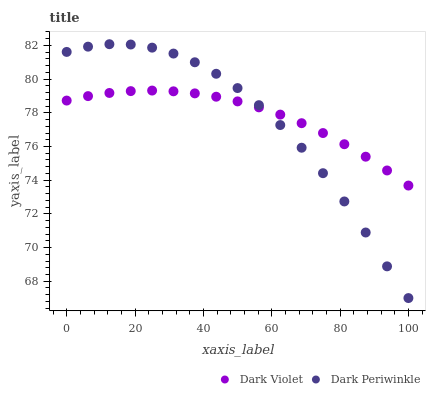Does Dark Periwinkle have the minimum area under the curve?
Answer yes or no. Yes. Does Dark Violet have the maximum area under the curve?
Answer yes or no. Yes. Does Dark Violet have the minimum area under the curve?
Answer yes or no. No. Is Dark Violet the smoothest?
Answer yes or no. Yes. Is Dark Periwinkle the roughest?
Answer yes or no. Yes. Is Dark Violet the roughest?
Answer yes or no. No. Does Dark Periwinkle have the lowest value?
Answer yes or no. Yes. Does Dark Violet have the lowest value?
Answer yes or no. No. Does Dark Periwinkle have the highest value?
Answer yes or no. Yes. Does Dark Violet have the highest value?
Answer yes or no. No. Does Dark Periwinkle intersect Dark Violet?
Answer yes or no. Yes. Is Dark Periwinkle less than Dark Violet?
Answer yes or no. No. Is Dark Periwinkle greater than Dark Violet?
Answer yes or no. No. 